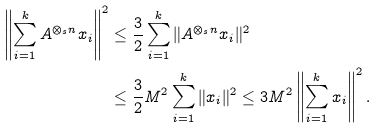<formula> <loc_0><loc_0><loc_500><loc_500>\left \| \sum _ { i = 1 } ^ { k } A ^ { \otimes _ { s } n } x _ { i } \right \| ^ { 2 } & \leq \frac { 3 } { 2 } \sum _ { i = 1 } ^ { k } \| A ^ { \otimes _ { s } n } x _ { i } \| ^ { 2 } \\ & \leq \frac { 3 } { 2 } M ^ { 2 } \sum _ { i = 1 } ^ { k } \| x _ { i } \| ^ { 2 } \leq 3 M ^ { 2 } \left \| \sum _ { i = 1 } ^ { k } x _ { i } \right \| ^ { 2 } .</formula> 